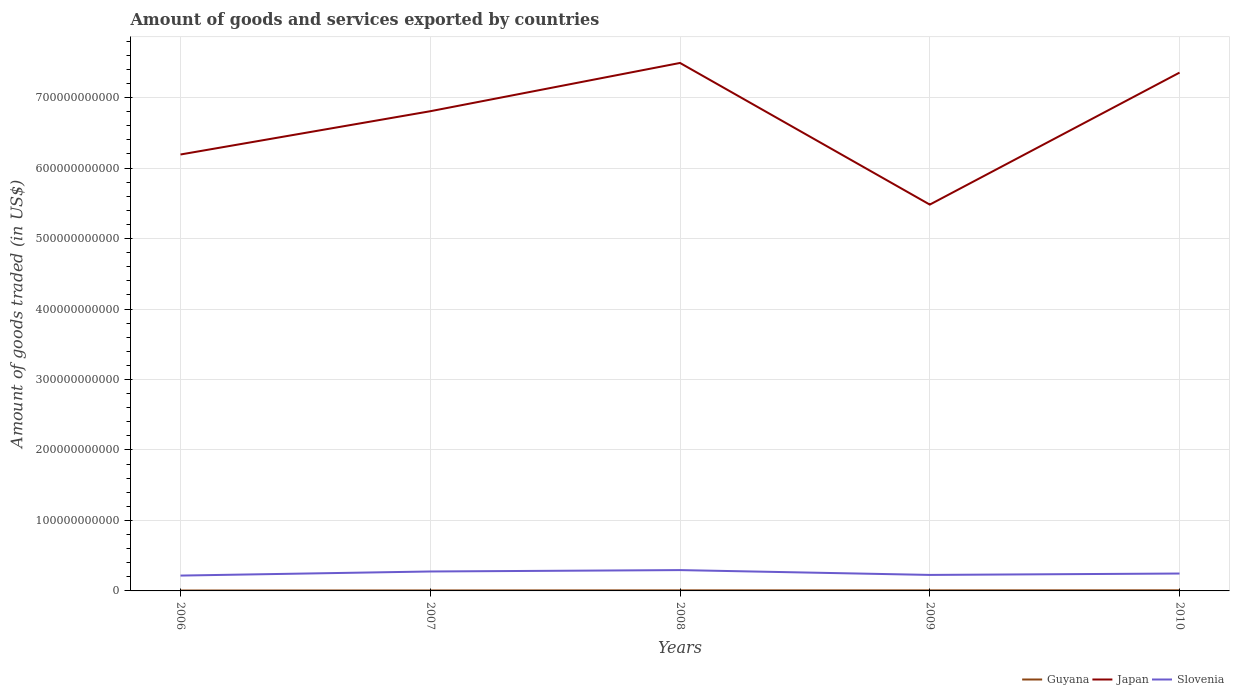Does the line corresponding to Slovenia intersect with the line corresponding to Japan?
Make the answer very short. No. Is the number of lines equal to the number of legend labels?
Keep it short and to the point. Yes. Across all years, what is the maximum total amount of goods and services exported in Slovenia?
Offer a very short reply. 2.18e+1. In which year was the total amount of goods and services exported in Japan maximum?
Offer a very short reply. 2009. What is the total total amount of goods and services exported in Japan in the graph?
Keep it short and to the point. -1.16e+11. What is the difference between the highest and the second highest total amount of goods and services exported in Slovenia?
Provide a short and direct response. 7.79e+09. What is the difference between the highest and the lowest total amount of goods and services exported in Japan?
Provide a succinct answer. 3. Is the total amount of goods and services exported in Slovenia strictly greater than the total amount of goods and services exported in Japan over the years?
Provide a succinct answer. Yes. How many years are there in the graph?
Offer a terse response. 5. What is the difference between two consecutive major ticks on the Y-axis?
Give a very brief answer. 1.00e+11. Are the values on the major ticks of Y-axis written in scientific E-notation?
Keep it short and to the point. No. Does the graph contain any zero values?
Your response must be concise. No. How are the legend labels stacked?
Make the answer very short. Horizontal. What is the title of the graph?
Provide a short and direct response. Amount of goods and services exported by countries. What is the label or title of the Y-axis?
Give a very brief answer. Amount of goods traded (in US$). What is the Amount of goods traded (in US$) in Guyana in 2006?
Provide a short and direct response. 5.80e+08. What is the Amount of goods traded (in US$) of Japan in 2006?
Offer a very short reply. 6.19e+11. What is the Amount of goods traded (in US$) of Slovenia in 2006?
Keep it short and to the point. 2.18e+1. What is the Amount of goods traded (in US$) in Guyana in 2007?
Your answer should be very brief. 6.75e+08. What is the Amount of goods traded (in US$) in Japan in 2007?
Ensure brevity in your answer.  6.81e+11. What is the Amount of goods traded (in US$) in Slovenia in 2007?
Offer a very short reply. 2.76e+1. What is the Amount of goods traded (in US$) of Guyana in 2008?
Offer a terse response. 8.02e+08. What is the Amount of goods traded (in US$) of Japan in 2008?
Provide a succinct answer. 7.49e+11. What is the Amount of goods traded (in US$) of Slovenia in 2008?
Your response must be concise. 2.96e+1. What is the Amount of goods traded (in US$) of Guyana in 2009?
Provide a short and direct response. 7.68e+08. What is the Amount of goods traded (in US$) of Japan in 2009?
Provide a short and direct response. 5.48e+11. What is the Amount of goods traded (in US$) of Slovenia in 2009?
Provide a short and direct response. 2.27e+1. What is the Amount of goods traded (in US$) of Guyana in 2010?
Your answer should be very brief. 8.71e+08. What is the Amount of goods traded (in US$) of Japan in 2010?
Your response must be concise. 7.35e+11. What is the Amount of goods traded (in US$) in Slovenia in 2010?
Your response must be concise. 2.47e+1. Across all years, what is the maximum Amount of goods traded (in US$) of Guyana?
Your response must be concise. 8.71e+08. Across all years, what is the maximum Amount of goods traded (in US$) in Japan?
Make the answer very short. 7.49e+11. Across all years, what is the maximum Amount of goods traded (in US$) of Slovenia?
Ensure brevity in your answer.  2.96e+1. Across all years, what is the minimum Amount of goods traded (in US$) of Guyana?
Make the answer very short. 5.80e+08. Across all years, what is the minimum Amount of goods traded (in US$) of Japan?
Offer a very short reply. 5.48e+11. Across all years, what is the minimum Amount of goods traded (in US$) of Slovenia?
Offer a terse response. 2.18e+1. What is the total Amount of goods traded (in US$) of Guyana in the graph?
Offer a very short reply. 3.70e+09. What is the total Amount of goods traded (in US$) of Japan in the graph?
Make the answer very short. 3.33e+12. What is the total Amount of goods traded (in US$) of Slovenia in the graph?
Your response must be concise. 1.26e+11. What is the difference between the Amount of goods traded (in US$) in Guyana in 2006 and that in 2007?
Give a very brief answer. -9.53e+07. What is the difference between the Amount of goods traded (in US$) of Japan in 2006 and that in 2007?
Offer a terse response. -6.14e+1. What is the difference between the Amount of goods traded (in US$) in Slovenia in 2006 and that in 2007?
Make the answer very short. -5.81e+09. What is the difference between the Amount of goods traded (in US$) in Guyana in 2006 and that in 2008?
Your answer should be very brief. -2.22e+08. What is the difference between the Amount of goods traded (in US$) of Japan in 2006 and that in 2008?
Your response must be concise. -1.30e+11. What is the difference between the Amount of goods traded (in US$) of Slovenia in 2006 and that in 2008?
Give a very brief answer. -7.79e+09. What is the difference between the Amount of goods traded (in US$) in Guyana in 2006 and that in 2009?
Your answer should be very brief. -1.89e+08. What is the difference between the Amount of goods traded (in US$) of Japan in 2006 and that in 2009?
Ensure brevity in your answer.  7.11e+1. What is the difference between the Amount of goods traded (in US$) of Slovenia in 2006 and that in 2009?
Make the answer very short. -9.34e+08. What is the difference between the Amount of goods traded (in US$) of Guyana in 2006 and that in 2010?
Your response must be concise. -2.92e+08. What is the difference between the Amount of goods traded (in US$) of Japan in 2006 and that in 2010?
Your response must be concise. -1.16e+11. What is the difference between the Amount of goods traded (in US$) in Slovenia in 2006 and that in 2010?
Your answer should be compact. -2.92e+09. What is the difference between the Amount of goods traded (in US$) in Guyana in 2007 and that in 2008?
Provide a succinct answer. -1.27e+08. What is the difference between the Amount of goods traded (in US$) of Japan in 2007 and that in 2008?
Your response must be concise. -6.85e+1. What is the difference between the Amount of goods traded (in US$) in Slovenia in 2007 and that in 2008?
Your response must be concise. -1.98e+09. What is the difference between the Amount of goods traded (in US$) of Guyana in 2007 and that in 2009?
Your response must be concise. -9.33e+07. What is the difference between the Amount of goods traded (in US$) of Japan in 2007 and that in 2009?
Ensure brevity in your answer.  1.32e+11. What is the difference between the Amount of goods traded (in US$) of Slovenia in 2007 and that in 2009?
Your answer should be compact. 4.87e+09. What is the difference between the Amount of goods traded (in US$) in Guyana in 2007 and that in 2010?
Ensure brevity in your answer.  -1.96e+08. What is the difference between the Amount of goods traded (in US$) of Japan in 2007 and that in 2010?
Keep it short and to the point. -5.48e+1. What is the difference between the Amount of goods traded (in US$) in Slovenia in 2007 and that in 2010?
Provide a succinct answer. 2.89e+09. What is the difference between the Amount of goods traded (in US$) in Guyana in 2008 and that in 2009?
Make the answer very short. 3.33e+07. What is the difference between the Amount of goods traded (in US$) of Japan in 2008 and that in 2009?
Provide a succinct answer. 2.01e+11. What is the difference between the Amount of goods traded (in US$) of Slovenia in 2008 and that in 2009?
Your answer should be very brief. 6.85e+09. What is the difference between the Amount of goods traded (in US$) of Guyana in 2008 and that in 2010?
Your answer should be very brief. -6.97e+07. What is the difference between the Amount of goods traded (in US$) in Japan in 2008 and that in 2010?
Keep it short and to the point. 1.37e+1. What is the difference between the Amount of goods traded (in US$) in Slovenia in 2008 and that in 2010?
Make the answer very short. 4.87e+09. What is the difference between the Amount of goods traded (in US$) of Guyana in 2009 and that in 2010?
Your answer should be compact. -1.03e+08. What is the difference between the Amount of goods traded (in US$) in Japan in 2009 and that in 2010?
Provide a short and direct response. -1.87e+11. What is the difference between the Amount of goods traded (in US$) in Slovenia in 2009 and that in 2010?
Provide a succinct answer. -1.98e+09. What is the difference between the Amount of goods traded (in US$) in Guyana in 2006 and the Amount of goods traded (in US$) in Japan in 2007?
Give a very brief answer. -6.80e+11. What is the difference between the Amount of goods traded (in US$) of Guyana in 2006 and the Amount of goods traded (in US$) of Slovenia in 2007?
Ensure brevity in your answer.  -2.70e+1. What is the difference between the Amount of goods traded (in US$) of Japan in 2006 and the Amount of goods traded (in US$) of Slovenia in 2007?
Give a very brief answer. 5.92e+11. What is the difference between the Amount of goods traded (in US$) in Guyana in 2006 and the Amount of goods traded (in US$) in Japan in 2008?
Ensure brevity in your answer.  -7.49e+11. What is the difference between the Amount of goods traded (in US$) in Guyana in 2006 and the Amount of goods traded (in US$) in Slovenia in 2008?
Offer a very short reply. -2.90e+1. What is the difference between the Amount of goods traded (in US$) of Japan in 2006 and the Amount of goods traded (in US$) of Slovenia in 2008?
Keep it short and to the point. 5.90e+11. What is the difference between the Amount of goods traded (in US$) of Guyana in 2006 and the Amount of goods traded (in US$) of Japan in 2009?
Provide a succinct answer. -5.48e+11. What is the difference between the Amount of goods traded (in US$) in Guyana in 2006 and the Amount of goods traded (in US$) in Slovenia in 2009?
Your answer should be very brief. -2.21e+1. What is the difference between the Amount of goods traded (in US$) in Japan in 2006 and the Amount of goods traded (in US$) in Slovenia in 2009?
Ensure brevity in your answer.  5.97e+11. What is the difference between the Amount of goods traded (in US$) in Guyana in 2006 and the Amount of goods traded (in US$) in Japan in 2010?
Give a very brief answer. -7.35e+11. What is the difference between the Amount of goods traded (in US$) in Guyana in 2006 and the Amount of goods traded (in US$) in Slovenia in 2010?
Provide a succinct answer. -2.41e+1. What is the difference between the Amount of goods traded (in US$) of Japan in 2006 and the Amount of goods traded (in US$) of Slovenia in 2010?
Your answer should be very brief. 5.95e+11. What is the difference between the Amount of goods traded (in US$) of Guyana in 2007 and the Amount of goods traded (in US$) of Japan in 2008?
Ensure brevity in your answer.  -7.48e+11. What is the difference between the Amount of goods traded (in US$) in Guyana in 2007 and the Amount of goods traded (in US$) in Slovenia in 2008?
Your answer should be very brief. -2.89e+1. What is the difference between the Amount of goods traded (in US$) of Japan in 2007 and the Amount of goods traded (in US$) of Slovenia in 2008?
Offer a terse response. 6.51e+11. What is the difference between the Amount of goods traded (in US$) of Guyana in 2007 and the Amount of goods traded (in US$) of Japan in 2009?
Keep it short and to the point. -5.47e+11. What is the difference between the Amount of goods traded (in US$) in Guyana in 2007 and the Amount of goods traded (in US$) in Slovenia in 2009?
Offer a very short reply. -2.20e+1. What is the difference between the Amount of goods traded (in US$) of Japan in 2007 and the Amount of goods traded (in US$) of Slovenia in 2009?
Ensure brevity in your answer.  6.58e+11. What is the difference between the Amount of goods traded (in US$) in Guyana in 2007 and the Amount of goods traded (in US$) in Japan in 2010?
Give a very brief answer. -7.35e+11. What is the difference between the Amount of goods traded (in US$) in Guyana in 2007 and the Amount of goods traded (in US$) in Slovenia in 2010?
Offer a very short reply. -2.40e+1. What is the difference between the Amount of goods traded (in US$) of Japan in 2007 and the Amount of goods traded (in US$) of Slovenia in 2010?
Offer a very short reply. 6.56e+11. What is the difference between the Amount of goods traded (in US$) in Guyana in 2008 and the Amount of goods traded (in US$) in Japan in 2009?
Your response must be concise. -5.47e+11. What is the difference between the Amount of goods traded (in US$) of Guyana in 2008 and the Amount of goods traded (in US$) of Slovenia in 2009?
Give a very brief answer. -2.19e+1. What is the difference between the Amount of goods traded (in US$) of Japan in 2008 and the Amount of goods traded (in US$) of Slovenia in 2009?
Provide a succinct answer. 7.26e+11. What is the difference between the Amount of goods traded (in US$) in Guyana in 2008 and the Amount of goods traded (in US$) in Japan in 2010?
Provide a short and direct response. -7.35e+11. What is the difference between the Amount of goods traded (in US$) in Guyana in 2008 and the Amount of goods traded (in US$) in Slovenia in 2010?
Ensure brevity in your answer.  -2.39e+1. What is the difference between the Amount of goods traded (in US$) of Japan in 2008 and the Amount of goods traded (in US$) of Slovenia in 2010?
Offer a terse response. 7.24e+11. What is the difference between the Amount of goods traded (in US$) of Guyana in 2009 and the Amount of goods traded (in US$) of Japan in 2010?
Ensure brevity in your answer.  -7.35e+11. What is the difference between the Amount of goods traded (in US$) of Guyana in 2009 and the Amount of goods traded (in US$) of Slovenia in 2010?
Your answer should be very brief. -2.39e+1. What is the difference between the Amount of goods traded (in US$) in Japan in 2009 and the Amount of goods traded (in US$) in Slovenia in 2010?
Give a very brief answer. 5.23e+11. What is the average Amount of goods traded (in US$) in Guyana per year?
Your answer should be compact. 7.39e+08. What is the average Amount of goods traded (in US$) in Japan per year?
Your answer should be very brief. 6.67e+11. What is the average Amount of goods traded (in US$) of Slovenia per year?
Give a very brief answer. 2.53e+1. In the year 2006, what is the difference between the Amount of goods traded (in US$) in Guyana and Amount of goods traded (in US$) in Japan?
Give a very brief answer. -6.19e+11. In the year 2006, what is the difference between the Amount of goods traded (in US$) of Guyana and Amount of goods traded (in US$) of Slovenia?
Offer a terse response. -2.12e+1. In the year 2006, what is the difference between the Amount of goods traded (in US$) of Japan and Amount of goods traded (in US$) of Slovenia?
Give a very brief answer. 5.97e+11. In the year 2007, what is the difference between the Amount of goods traded (in US$) in Guyana and Amount of goods traded (in US$) in Japan?
Your answer should be very brief. -6.80e+11. In the year 2007, what is the difference between the Amount of goods traded (in US$) of Guyana and Amount of goods traded (in US$) of Slovenia?
Give a very brief answer. -2.69e+1. In the year 2007, what is the difference between the Amount of goods traded (in US$) of Japan and Amount of goods traded (in US$) of Slovenia?
Offer a terse response. 6.53e+11. In the year 2008, what is the difference between the Amount of goods traded (in US$) of Guyana and Amount of goods traded (in US$) of Japan?
Make the answer very short. -7.48e+11. In the year 2008, what is the difference between the Amount of goods traded (in US$) in Guyana and Amount of goods traded (in US$) in Slovenia?
Your answer should be compact. -2.88e+1. In the year 2008, what is the difference between the Amount of goods traded (in US$) of Japan and Amount of goods traded (in US$) of Slovenia?
Give a very brief answer. 7.20e+11. In the year 2009, what is the difference between the Amount of goods traded (in US$) of Guyana and Amount of goods traded (in US$) of Japan?
Keep it short and to the point. -5.47e+11. In the year 2009, what is the difference between the Amount of goods traded (in US$) of Guyana and Amount of goods traded (in US$) of Slovenia?
Make the answer very short. -2.19e+1. In the year 2009, what is the difference between the Amount of goods traded (in US$) in Japan and Amount of goods traded (in US$) in Slovenia?
Offer a terse response. 5.25e+11. In the year 2010, what is the difference between the Amount of goods traded (in US$) of Guyana and Amount of goods traded (in US$) of Japan?
Provide a short and direct response. -7.35e+11. In the year 2010, what is the difference between the Amount of goods traded (in US$) of Guyana and Amount of goods traded (in US$) of Slovenia?
Offer a very short reply. -2.38e+1. In the year 2010, what is the difference between the Amount of goods traded (in US$) in Japan and Amount of goods traded (in US$) in Slovenia?
Provide a succinct answer. 7.11e+11. What is the ratio of the Amount of goods traded (in US$) in Guyana in 2006 to that in 2007?
Give a very brief answer. 0.86. What is the ratio of the Amount of goods traded (in US$) in Japan in 2006 to that in 2007?
Keep it short and to the point. 0.91. What is the ratio of the Amount of goods traded (in US$) of Slovenia in 2006 to that in 2007?
Keep it short and to the point. 0.79. What is the ratio of the Amount of goods traded (in US$) of Guyana in 2006 to that in 2008?
Ensure brevity in your answer.  0.72. What is the ratio of the Amount of goods traded (in US$) of Japan in 2006 to that in 2008?
Provide a succinct answer. 0.83. What is the ratio of the Amount of goods traded (in US$) in Slovenia in 2006 to that in 2008?
Provide a succinct answer. 0.74. What is the ratio of the Amount of goods traded (in US$) in Guyana in 2006 to that in 2009?
Provide a succinct answer. 0.75. What is the ratio of the Amount of goods traded (in US$) of Japan in 2006 to that in 2009?
Keep it short and to the point. 1.13. What is the ratio of the Amount of goods traded (in US$) of Slovenia in 2006 to that in 2009?
Make the answer very short. 0.96. What is the ratio of the Amount of goods traded (in US$) of Guyana in 2006 to that in 2010?
Offer a terse response. 0.67. What is the ratio of the Amount of goods traded (in US$) in Japan in 2006 to that in 2010?
Make the answer very short. 0.84. What is the ratio of the Amount of goods traded (in US$) of Slovenia in 2006 to that in 2010?
Keep it short and to the point. 0.88. What is the ratio of the Amount of goods traded (in US$) of Guyana in 2007 to that in 2008?
Keep it short and to the point. 0.84. What is the ratio of the Amount of goods traded (in US$) of Japan in 2007 to that in 2008?
Provide a short and direct response. 0.91. What is the ratio of the Amount of goods traded (in US$) in Slovenia in 2007 to that in 2008?
Make the answer very short. 0.93. What is the ratio of the Amount of goods traded (in US$) of Guyana in 2007 to that in 2009?
Provide a short and direct response. 0.88. What is the ratio of the Amount of goods traded (in US$) of Japan in 2007 to that in 2009?
Give a very brief answer. 1.24. What is the ratio of the Amount of goods traded (in US$) of Slovenia in 2007 to that in 2009?
Your response must be concise. 1.21. What is the ratio of the Amount of goods traded (in US$) in Guyana in 2007 to that in 2010?
Your response must be concise. 0.77. What is the ratio of the Amount of goods traded (in US$) in Japan in 2007 to that in 2010?
Make the answer very short. 0.93. What is the ratio of the Amount of goods traded (in US$) of Slovenia in 2007 to that in 2010?
Make the answer very short. 1.12. What is the ratio of the Amount of goods traded (in US$) of Guyana in 2008 to that in 2009?
Your answer should be compact. 1.04. What is the ratio of the Amount of goods traded (in US$) in Japan in 2008 to that in 2009?
Provide a succinct answer. 1.37. What is the ratio of the Amount of goods traded (in US$) of Slovenia in 2008 to that in 2009?
Ensure brevity in your answer.  1.3. What is the ratio of the Amount of goods traded (in US$) of Japan in 2008 to that in 2010?
Ensure brevity in your answer.  1.02. What is the ratio of the Amount of goods traded (in US$) in Slovenia in 2008 to that in 2010?
Offer a terse response. 1.2. What is the ratio of the Amount of goods traded (in US$) of Guyana in 2009 to that in 2010?
Your answer should be very brief. 0.88. What is the ratio of the Amount of goods traded (in US$) in Japan in 2009 to that in 2010?
Provide a short and direct response. 0.75. What is the ratio of the Amount of goods traded (in US$) in Slovenia in 2009 to that in 2010?
Your answer should be compact. 0.92. What is the difference between the highest and the second highest Amount of goods traded (in US$) in Guyana?
Your response must be concise. 6.97e+07. What is the difference between the highest and the second highest Amount of goods traded (in US$) in Japan?
Give a very brief answer. 1.37e+1. What is the difference between the highest and the second highest Amount of goods traded (in US$) of Slovenia?
Your answer should be compact. 1.98e+09. What is the difference between the highest and the lowest Amount of goods traded (in US$) of Guyana?
Your answer should be compact. 2.92e+08. What is the difference between the highest and the lowest Amount of goods traded (in US$) in Japan?
Provide a succinct answer. 2.01e+11. What is the difference between the highest and the lowest Amount of goods traded (in US$) of Slovenia?
Make the answer very short. 7.79e+09. 